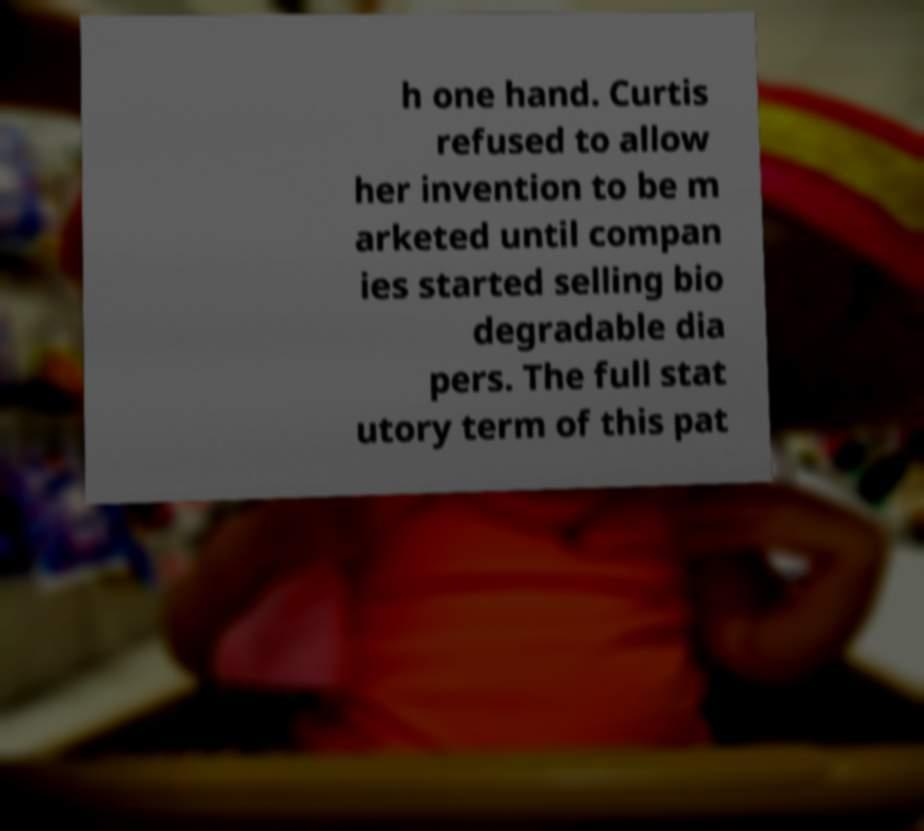Please read and relay the text visible in this image. What does it say? h one hand. Curtis refused to allow her invention to be m arketed until compan ies started selling bio degradable dia pers. The full stat utory term of this pat 